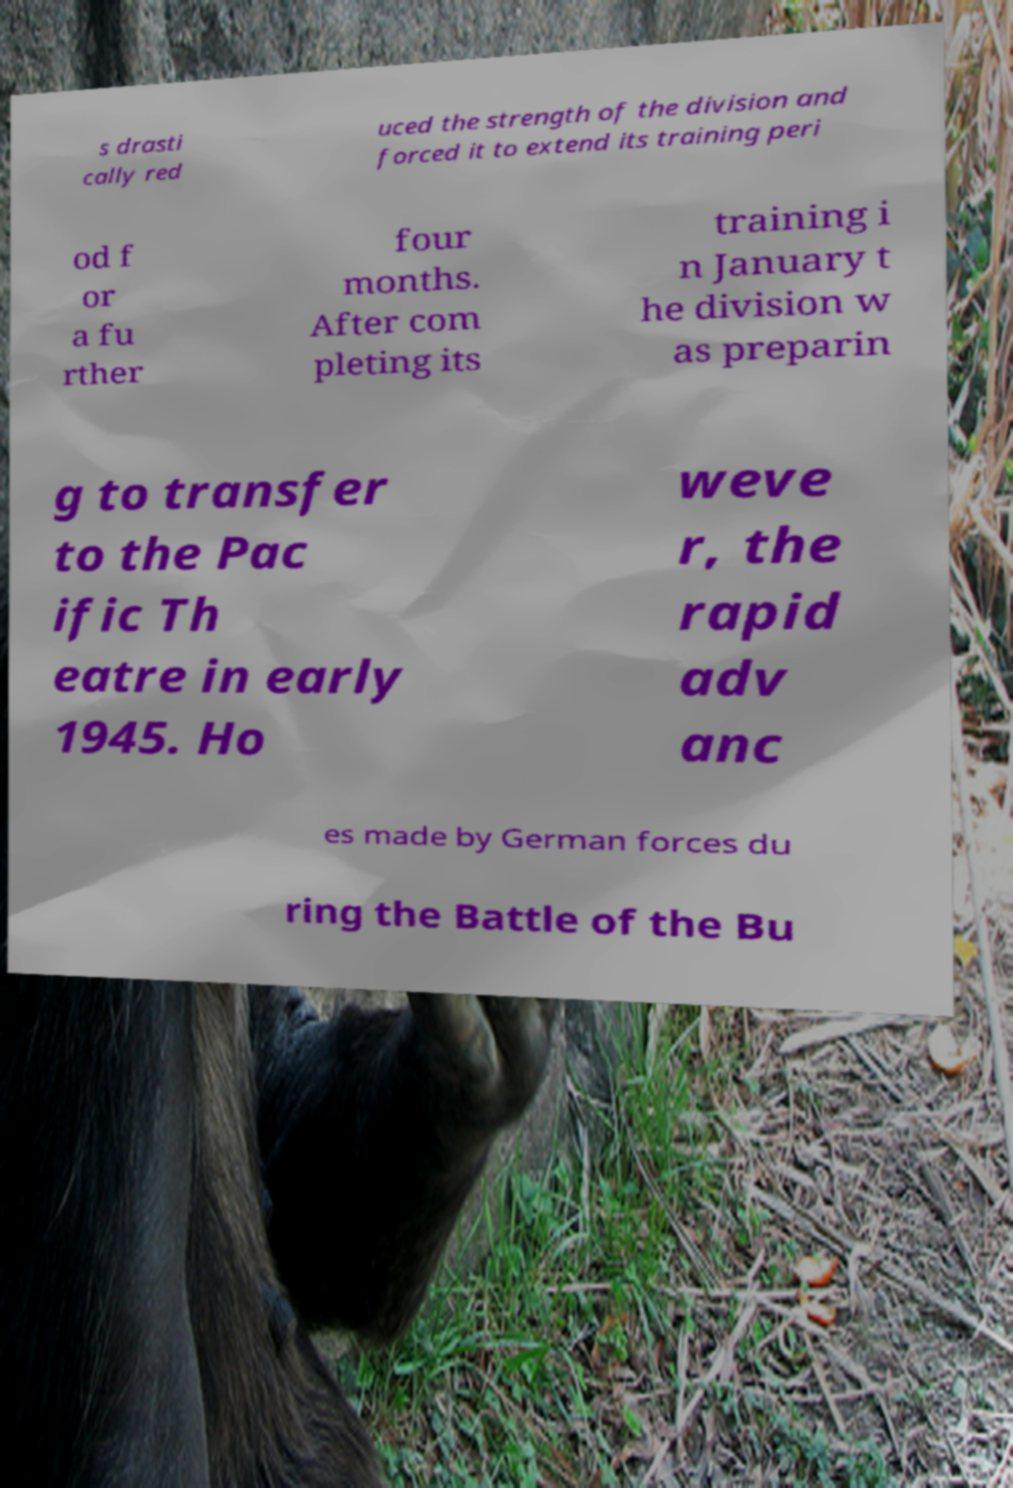Could you extract and type out the text from this image? s drasti cally red uced the strength of the division and forced it to extend its training peri od f or a fu rther four months. After com pleting its training i n January t he division w as preparin g to transfer to the Pac ific Th eatre in early 1945. Ho weve r, the rapid adv anc es made by German forces du ring the Battle of the Bu 